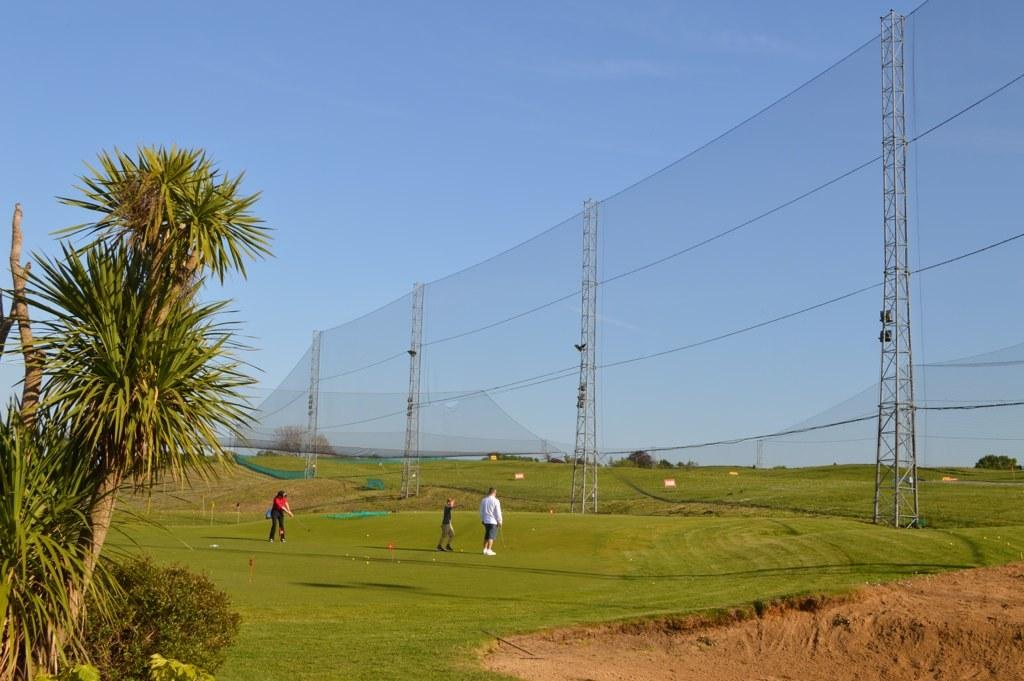What are the three persons in the image doing? The three persons in the image are playing golf. What can be seen on the left side of the image? There are trees on the left side of the image. What is present on the right side of the image? There is a net on the right side of the image. What is visible at the top of the image? The sky is visible at the top of the image. What type of fuel is being used by the golf cart in the image? There is no golf cart present in the image, so it is not possible to determine what type of fuel is being used. Can you tell me how many beetles are crawling on the golf course in the image? There are no beetles visible in the image; it features three persons playing golf, trees, a net, and the sky. 